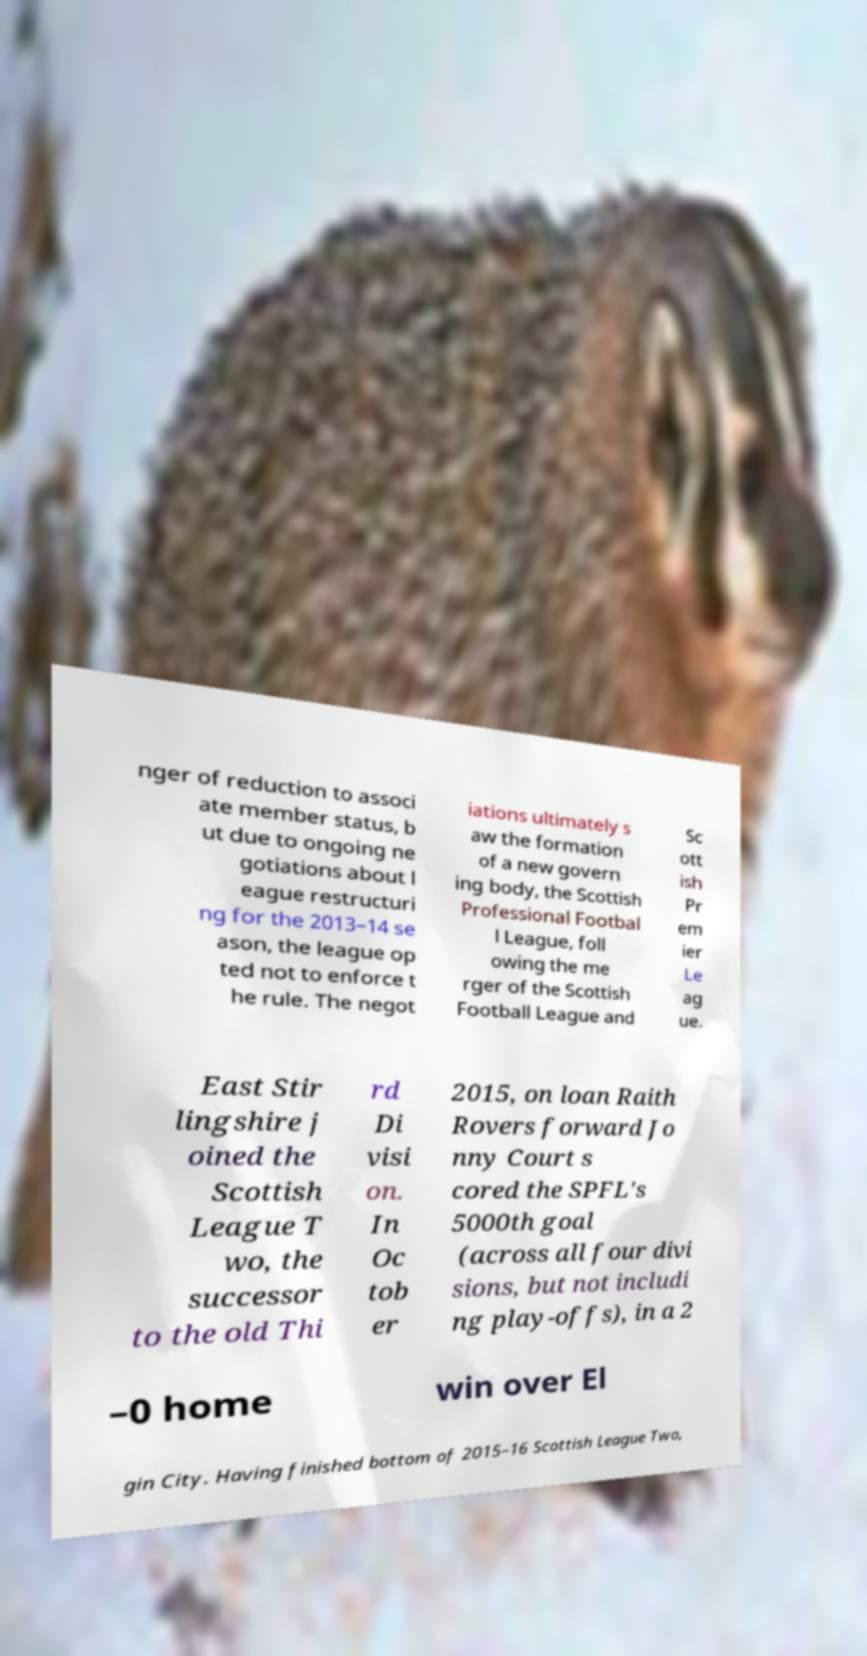Could you extract and type out the text from this image? nger of reduction to associ ate member status, b ut due to ongoing ne gotiations about l eague restructuri ng for the 2013–14 se ason, the league op ted not to enforce t he rule. The negot iations ultimately s aw the formation of a new govern ing body, the Scottish Professional Footbal l League, foll owing the me rger of the Scottish Football League and Sc ott ish Pr em ier Le ag ue. East Stir lingshire j oined the Scottish League T wo, the successor to the old Thi rd Di visi on. In Oc tob er 2015, on loan Raith Rovers forward Jo nny Court s cored the SPFL's 5000th goal (across all four divi sions, but not includi ng play-offs), in a 2 –0 home win over El gin City. Having finished bottom of 2015–16 Scottish League Two, 